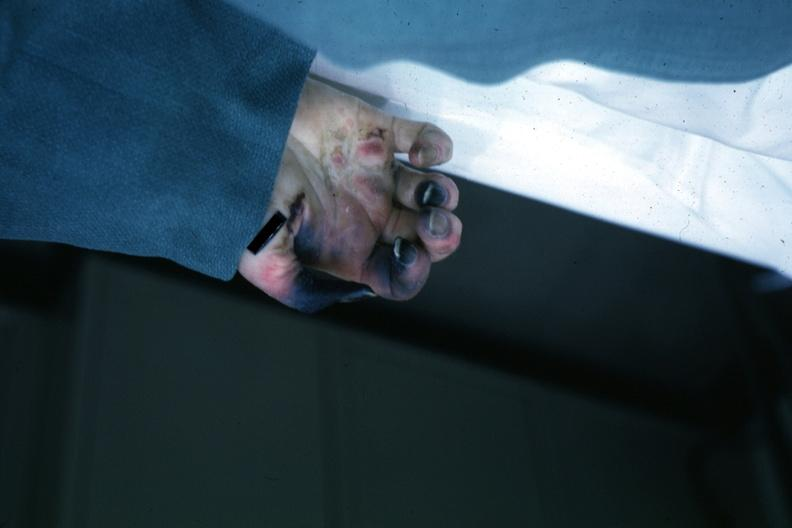s cachexia present?
Answer the question using a single word or phrase. No 